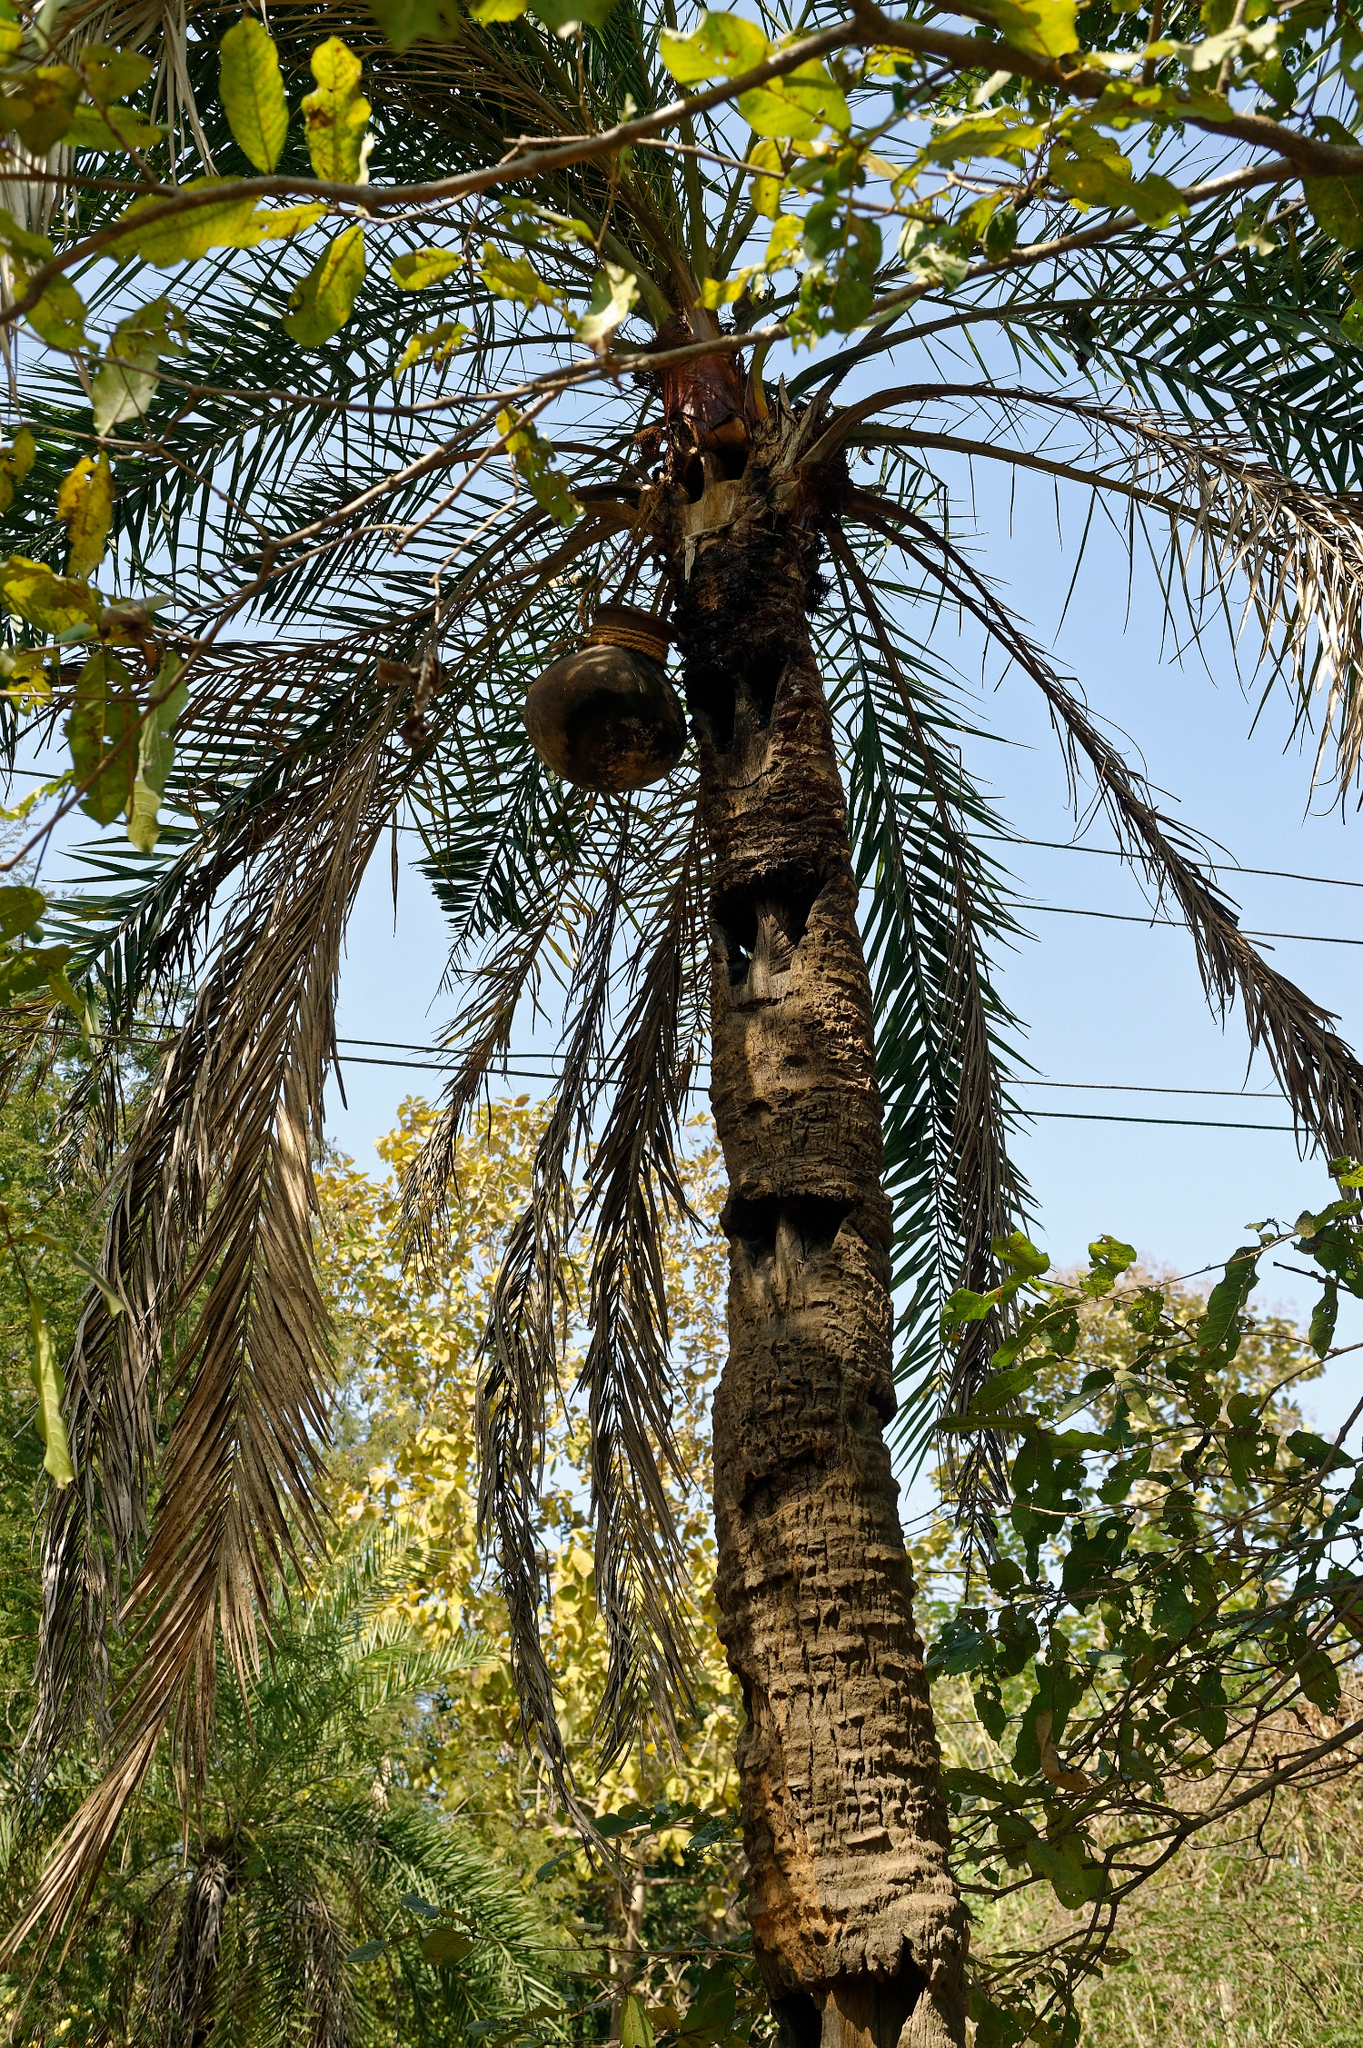Write a detailed description of the given image. The image features a tall palm tree whose rough, brown bark rises up towards the azure sky. The tree's fronds, a mix of lush green and dried yellow, wave gently in the breeze. Suspended from one of the palm's branches is a rustic, round birdhouse, which provides shelter to the local bird species. The serene backdrop is a clear blue sky with a smattering of fluffy white clouds, imparting a sense of tranquility to the scene. Surrounding the palm tree, various foliage in shades of green and gold add depth and vibrancy to the composition, creating a picturesque snapshot of nature. 